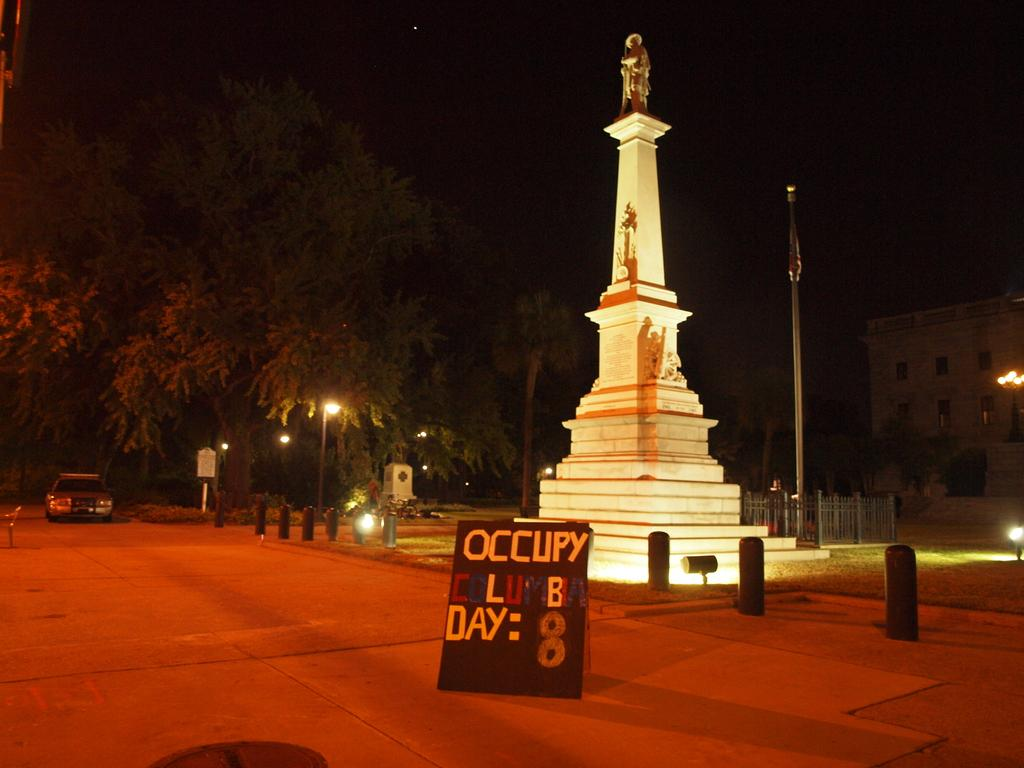<image>
Share a concise interpretation of the image provided. A sign that says occupy at the top of it says this is day 8. 